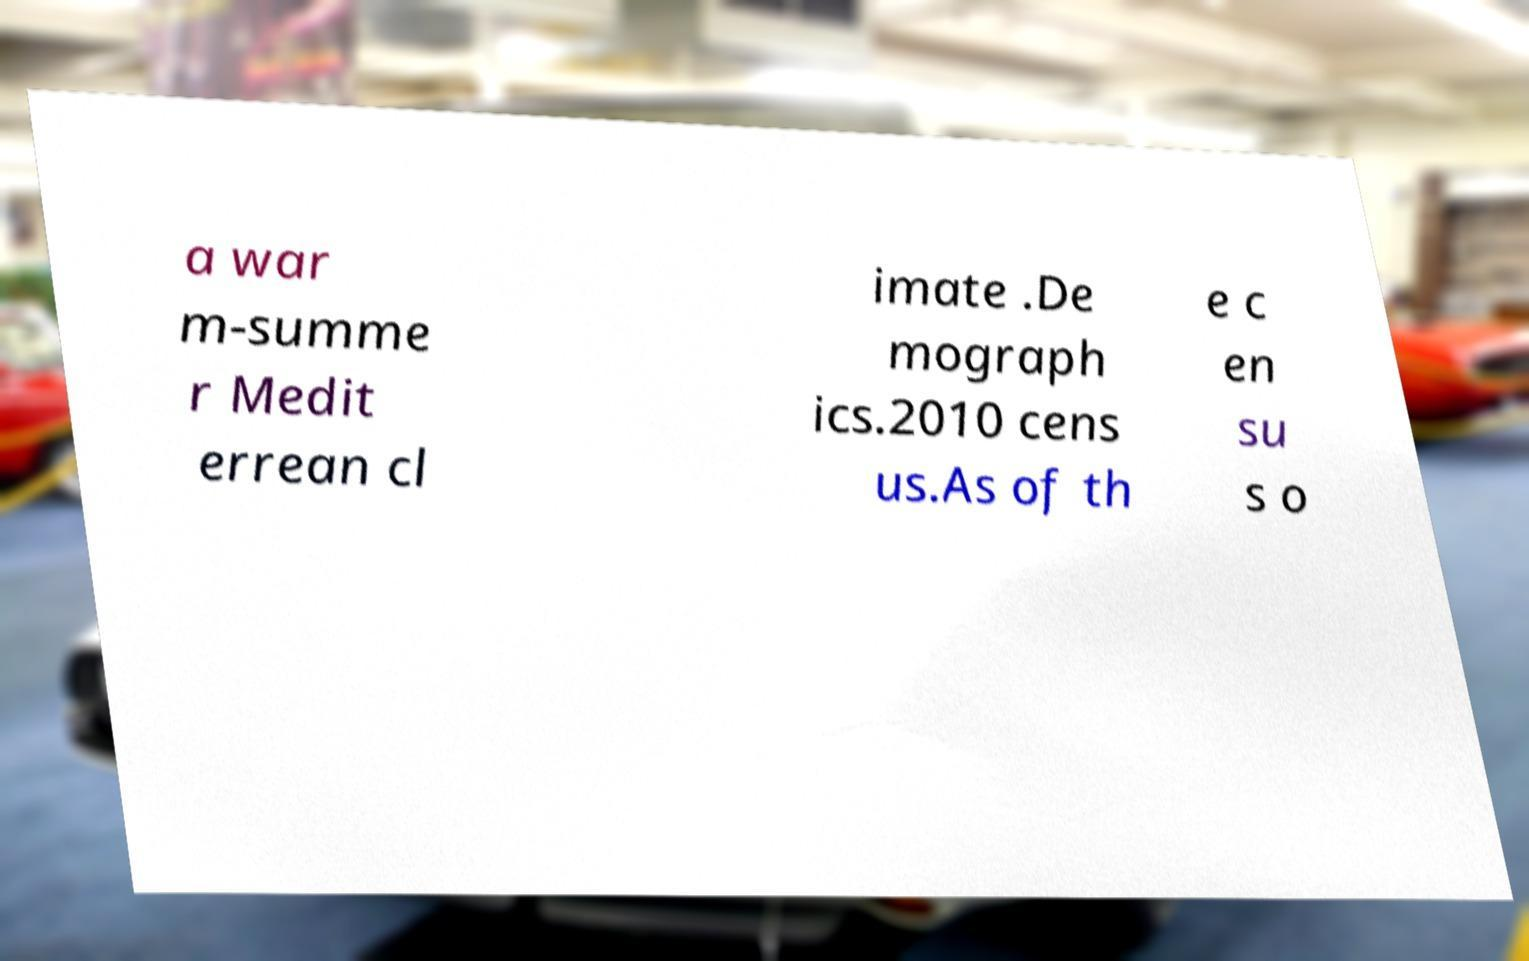Could you assist in decoding the text presented in this image and type it out clearly? a war m-summe r Medit errean cl imate .De mograph ics.2010 cens us.As of th e c en su s o 